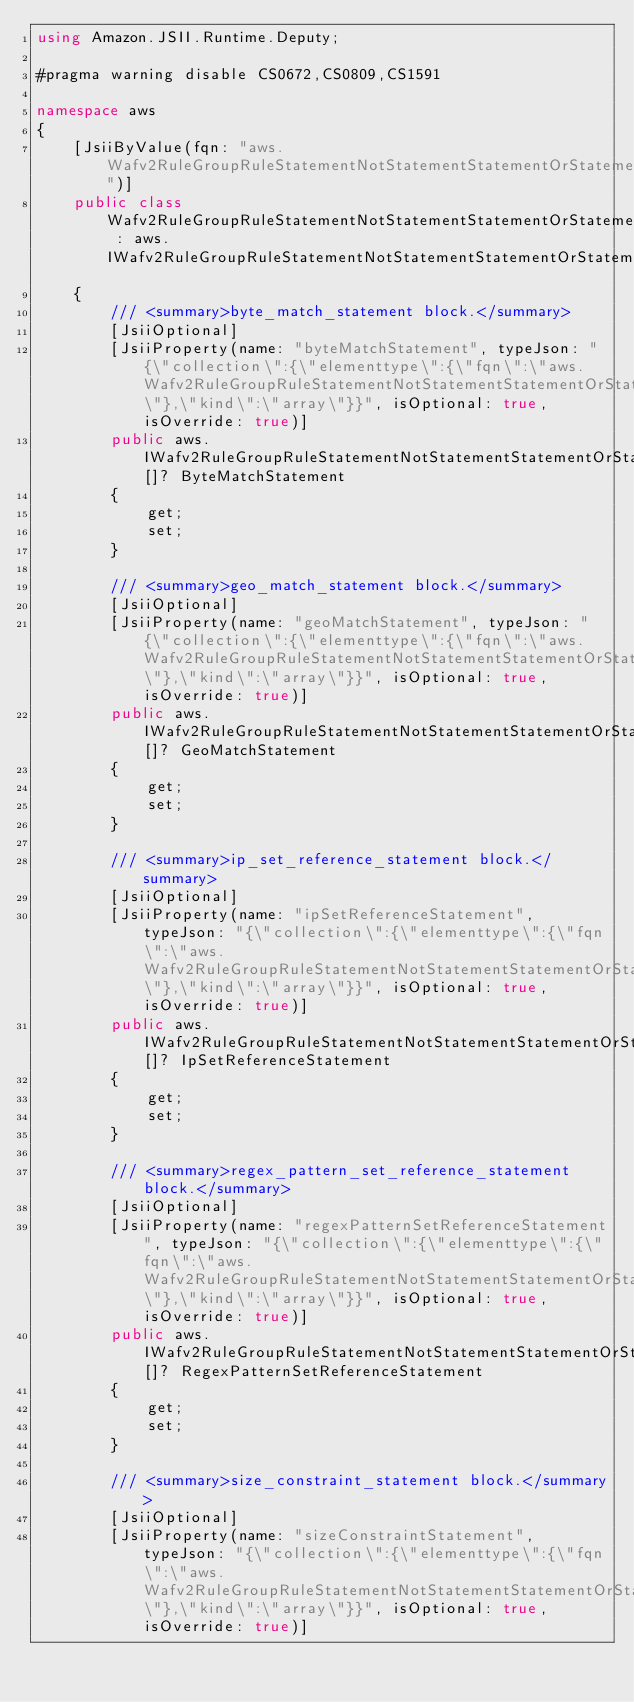Convert code to text. <code><loc_0><loc_0><loc_500><loc_500><_C#_>using Amazon.JSII.Runtime.Deputy;

#pragma warning disable CS0672,CS0809,CS1591

namespace aws
{
    [JsiiByValue(fqn: "aws.Wafv2RuleGroupRuleStatementNotStatementStatementOrStatementStatement")]
    public class Wafv2RuleGroupRuleStatementNotStatementStatementOrStatementStatement : aws.IWafv2RuleGroupRuleStatementNotStatementStatementOrStatementStatement
    {
        /// <summary>byte_match_statement block.</summary>
        [JsiiOptional]
        [JsiiProperty(name: "byteMatchStatement", typeJson: "{\"collection\":{\"elementtype\":{\"fqn\":\"aws.Wafv2RuleGroupRuleStatementNotStatementStatementOrStatementStatementByteMatchStatement\"},\"kind\":\"array\"}}", isOptional: true, isOverride: true)]
        public aws.IWafv2RuleGroupRuleStatementNotStatementStatementOrStatementStatementByteMatchStatement[]? ByteMatchStatement
        {
            get;
            set;
        }

        /// <summary>geo_match_statement block.</summary>
        [JsiiOptional]
        [JsiiProperty(name: "geoMatchStatement", typeJson: "{\"collection\":{\"elementtype\":{\"fqn\":\"aws.Wafv2RuleGroupRuleStatementNotStatementStatementOrStatementStatementGeoMatchStatement\"},\"kind\":\"array\"}}", isOptional: true, isOverride: true)]
        public aws.IWafv2RuleGroupRuleStatementNotStatementStatementOrStatementStatementGeoMatchStatement[]? GeoMatchStatement
        {
            get;
            set;
        }

        /// <summary>ip_set_reference_statement block.</summary>
        [JsiiOptional]
        [JsiiProperty(name: "ipSetReferenceStatement", typeJson: "{\"collection\":{\"elementtype\":{\"fqn\":\"aws.Wafv2RuleGroupRuleStatementNotStatementStatementOrStatementStatementIpSetReferenceStatement\"},\"kind\":\"array\"}}", isOptional: true, isOverride: true)]
        public aws.IWafv2RuleGroupRuleStatementNotStatementStatementOrStatementStatementIpSetReferenceStatement[]? IpSetReferenceStatement
        {
            get;
            set;
        }

        /// <summary>regex_pattern_set_reference_statement block.</summary>
        [JsiiOptional]
        [JsiiProperty(name: "regexPatternSetReferenceStatement", typeJson: "{\"collection\":{\"elementtype\":{\"fqn\":\"aws.Wafv2RuleGroupRuleStatementNotStatementStatementOrStatementStatementRegexPatternSetReferenceStatement\"},\"kind\":\"array\"}}", isOptional: true, isOverride: true)]
        public aws.IWafv2RuleGroupRuleStatementNotStatementStatementOrStatementStatementRegexPatternSetReferenceStatement[]? RegexPatternSetReferenceStatement
        {
            get;
            set;
        }

        /// <summary>size_constraint_statement block.</summary>
        [JsiiOptional]
        [JsiiProperty(name: "sizeConstraintStatement", typeJson: "{\"collection\":{\"elementtype\":{\"fqn\":\"aws.Wafv2RuleGroupRuleStatementNotStatementStatementOrStatementStatementSizeConstraintStatement\"},\"kind\":\"array\"}}", isOptional: true, isOverride: true)]</code> 